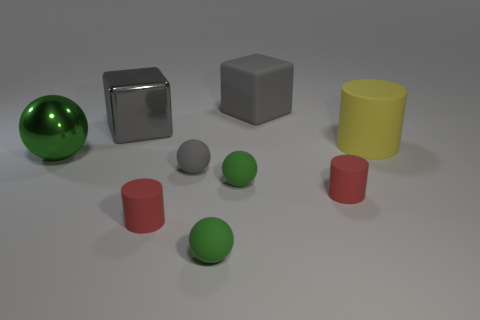Is there anything else that has the same size as the gray rubber sphere?
Your answer should be compact. Yes. Are there any small cyan matte cylinders?
Give a very brief answer. No. There is a red cylinder on the left side of the rubber thing behind the cylinder behind the big green metal sphere; what is its material?
Your response must be concise. Rubber. Is the shape of the large gray rubber thing the same as the red rubber thing left of the gray rubber cube?
Your answer should be very brief. No. How many large yellow rubber things have the same shape as the gray metallic object?
Your answer should be compact. 0. There is a gray metal thing; what shape is it?
Keep it short and to the point. Cube. What size is the gray thing that is on the right side of the gray matte object that is in front of the yellow cylinder?
Offer a terse response. Large. How many things are large green metallic objects or small green rubber objects?
Provide a short and direct response. 3. Does the big yellow thing have the same shape as the gray metallic object?
Provide a short and direct response. No. Are there any large green things that have the same material as the large sphere?
Ensure brevity in your answer.  No. 